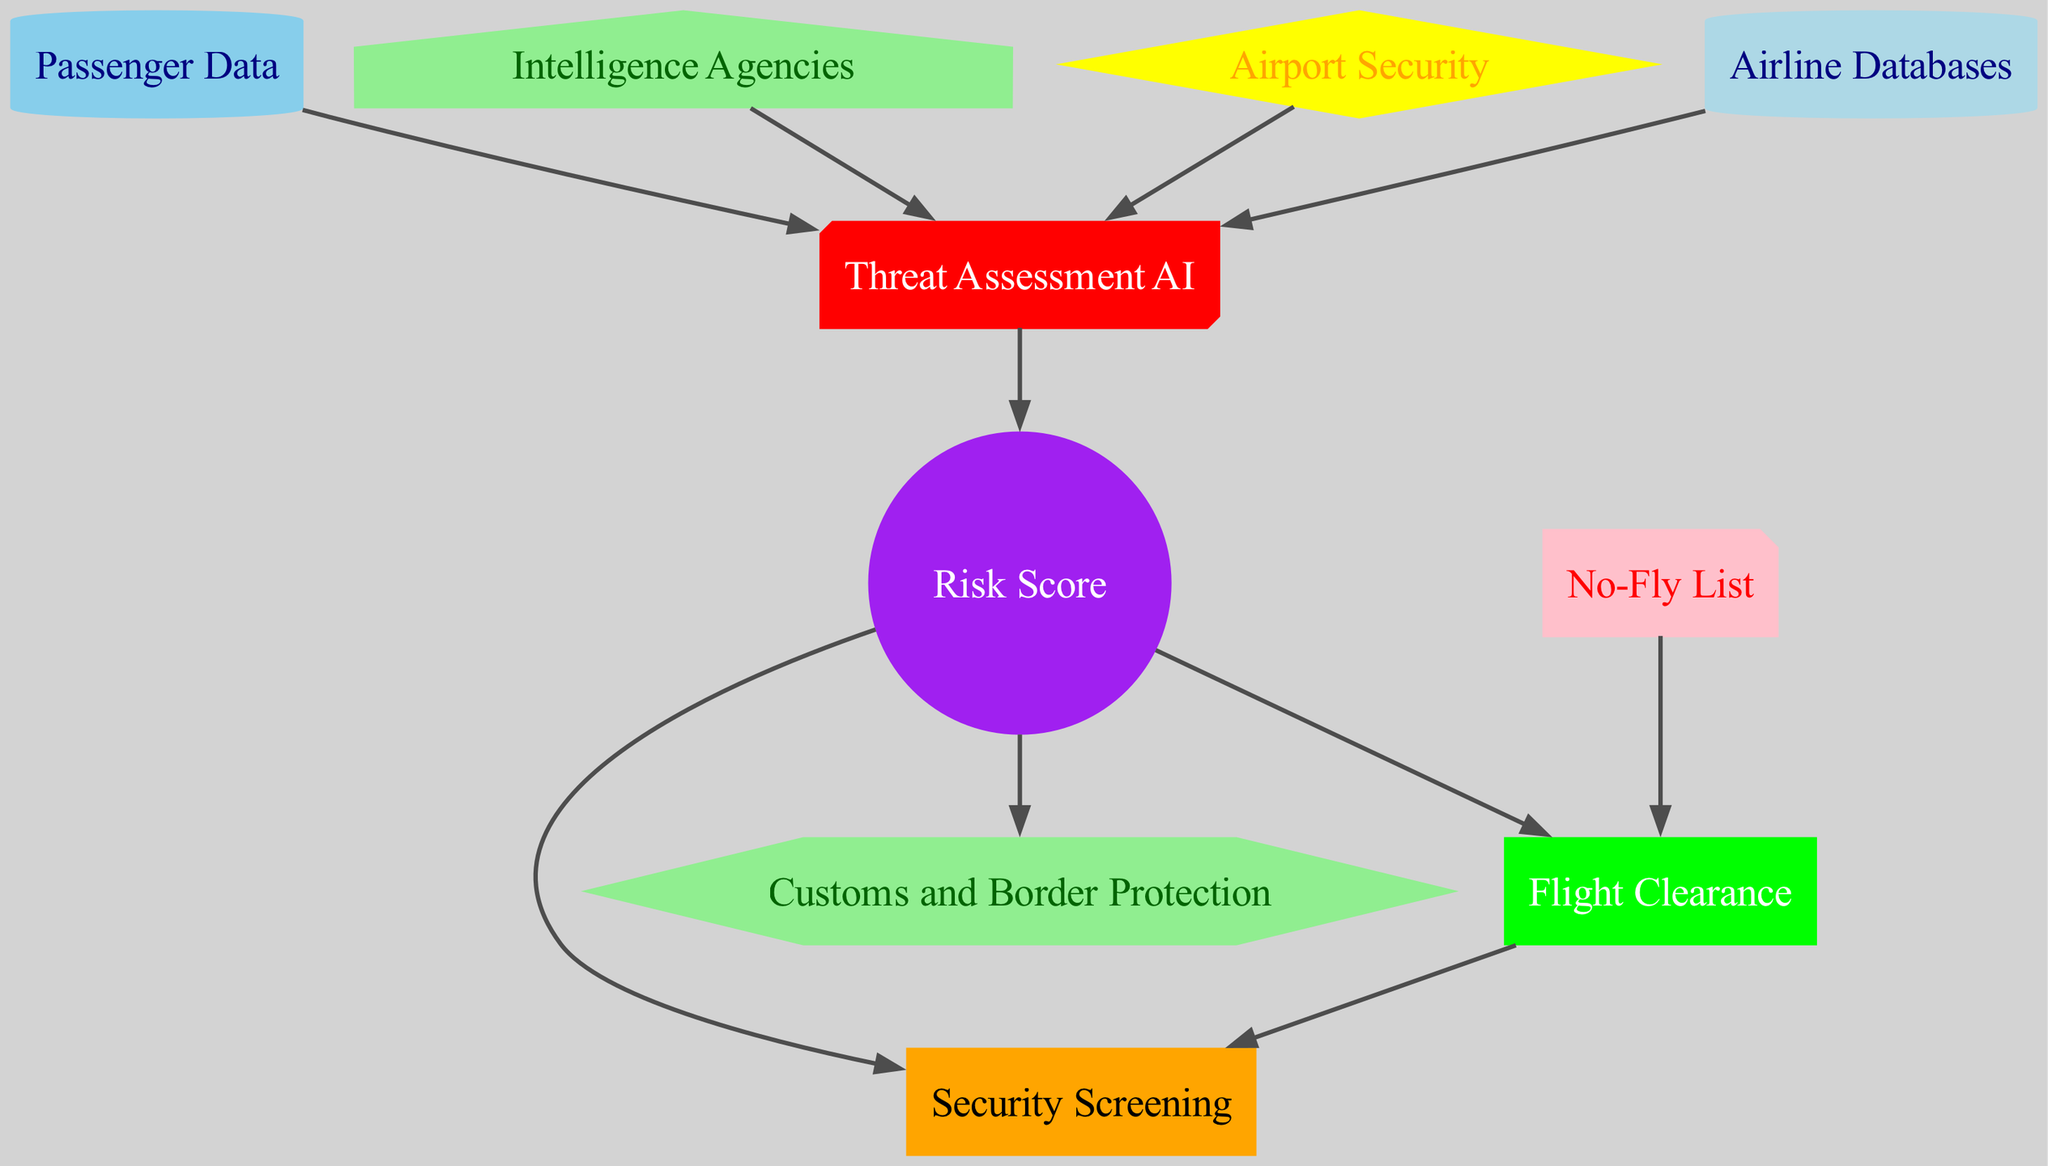What is the total number of nodes in the diagram? The diagram includes the following nodes: Passenger Data, Intelligence Agencies, Airport Security, Airline Databases, Threat Assessment AI, Security Screening, Customs and Border Protection, No-Fly List, Risk Score, and Flight Clearance. Counting each node results in a total of 10 nodes.
Answer: 10 Which node is responsible for evaluating incoming passenger data? Passenger Data is the source node that directly feeds into the Threat Assessment AI, which evaluates the incoming data. Therefore, Passenger Data is responsible for evaluating incoming passenger information.
Answer: Passenger Data What type of data flows from Intelligence Agencies to the Threat Assessment AI? In the diagram, the arrows symbolize the flow of information, so information from Intelligence Agencies is sent to the Threat Assessment AI for processing. Thus, the type of data can be described as "intelligence data."
Answer: Intelligence data How many edges lead out of the Risk Score node? The Risk Score node has three outgoing edges, connecting to Security Screening, Customs and Border Protection, and Flight Clearance. By counting these connections, we find that there are three edges leading out of the Risk Score node.
Answer: 3 Which decision point uses the No-Fly List as an input? The Flight Clearance node utilizes the No-Fly List, as indicated by the directed edge from No-Fly List to Flight Clearance. This means that the Flight Clearance decision point incorporates the No-Fly List into its assessment.
Answer: Flight Clearance What are the outputs of the Threat Assessment AI? The Threat Assessment AI has two outputs: Risk Score and Flight Clearance. These outputs indicate what decisions are made based on the assessment of the incoming data.
Answer: Risk Score and Flight Clearance Which nodes are connected to the Security Screening node? Security Screening has three incoming edges directed towards it: one from Risk Score and another from Flight Clearance. This indicates that Security Screening relies on both the Risk Score and the decision made at Flight Clearance to proceed.
Answer: Risk Score and Flight Clearance What shapes are used to represent the Threat Assessment AI and Customs and Border Protection nodes? The Threat Assessment AI is represented as a box3d shape and styled in red, while Customs and Border Protection is depicted as a hexagon shape and styled in light green according to the diagram's node styles.
Answer: box3d and hexagon 